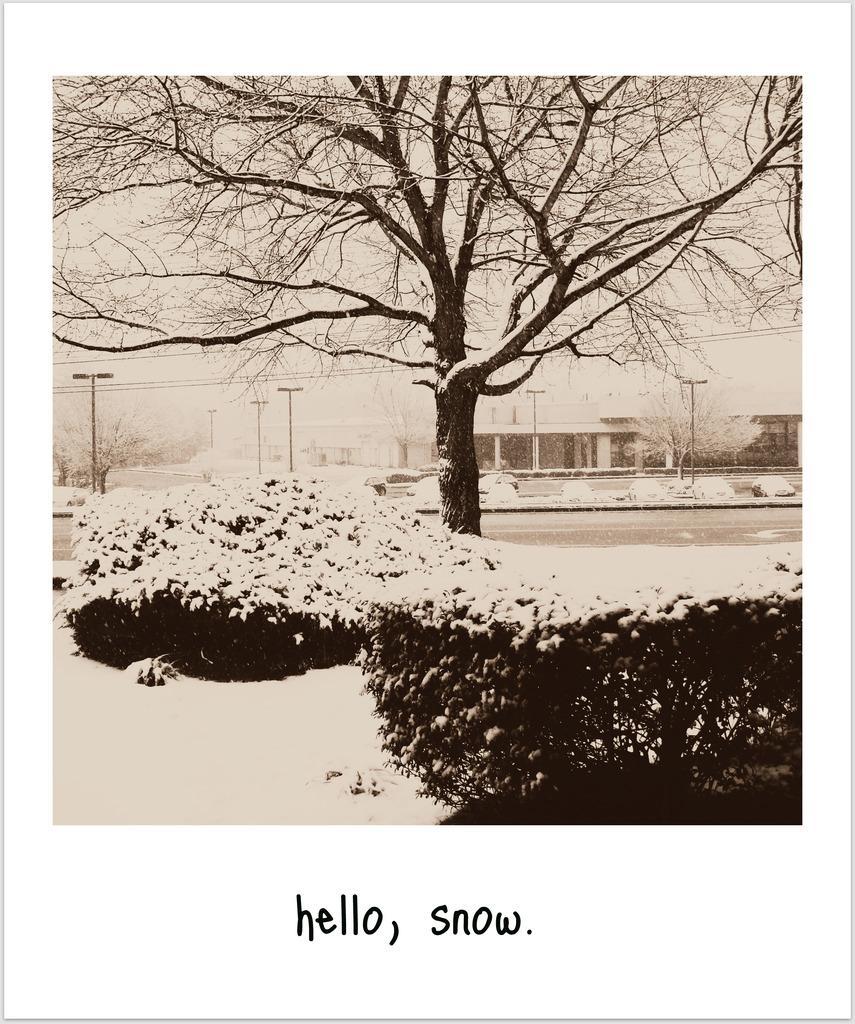Describe this image in one or two sentences. In this black and white image there are plants, trees, poles, buildings and at the bottom of the image there is some text. 